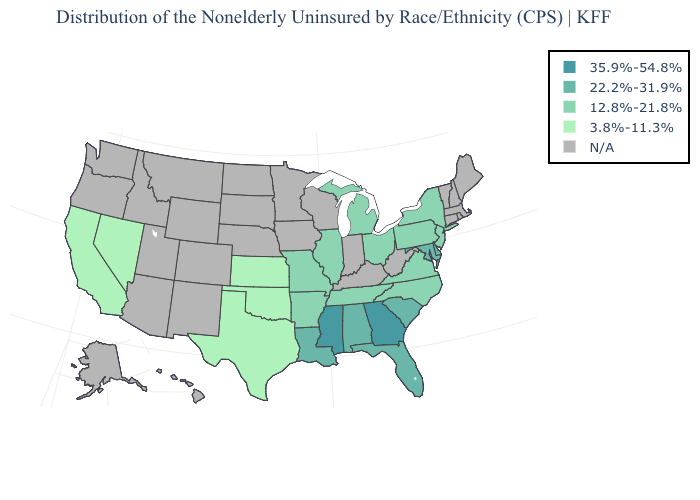Does the map have missing data?
Answer briefly. Yes. What is the value of Mississippi?
Keep it brief. 35.9%-54.8%. What is the value of Iowa?
Concise answer only. N/A. Name the states that have a value in the range N/A?
Write a very short answer. Alaska, Arizona, Colorado, Connecticut, Hawaii, Idaho, Indiana, Iowa, Kentucky, Maine, Massachusetts, Minnesota, Montana, Nebraska, New Hampshire, New Mexico, North Dakota, Oregon, Rhode Island, South Dakota, Utah, Vermont, Washington, West Virginia, Wisconsin, Wyoming. Among the states that border California , which have the highest value?
Answer briefly. Nevada. Name the states that have a value in the range 35.9%-54.8%?
Keep it brief. Georgia, Mississippi. Name the states that have a value in the range 35.9%-54.8%?
Short answer required. Georgia, Mississippi. Name the states that have a value in the range 12.8%-21.8%?
Short answer required. Arkansas, Illinois, Michigan, Missouri, New Jersey, New York, North Carolina, Ohio, Pennsylvania, Tennessee, Virginia. What is the lowest value in the USA?
Write a very short answer. 3.8%-11.3%. What is the highest value in the USA?
Short answer required. 35.9%-54.8%. Among the states that border Maryland , does Delaware have the highest value?
Write a very short answer. Yes. What is the value of Illinois?
Give a very brief answer. 12.8%-21.8%. Is the legend a continuous bar?
Give a very brief answer. No. Which states have the lowest value in the West?
Concise answer only. California, Nevada. 